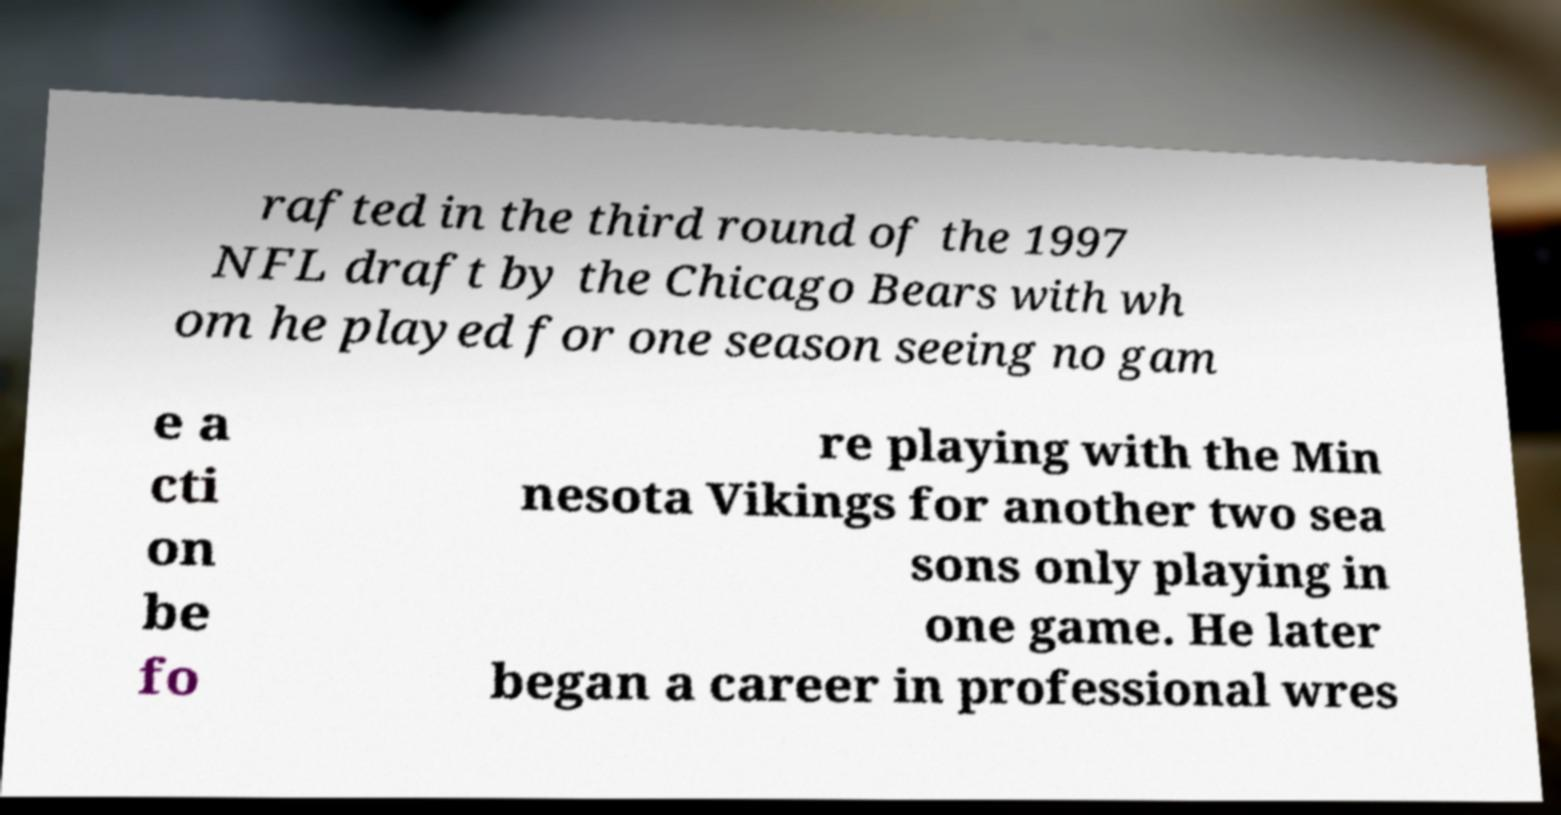Please read and relay the text visible in this image. What does it say? rafted in the third round of the 1997 NFL draft by the Chicago Bears with wh om he played for one season seeing no gam e a cti on be fo re playing with the Min nesota Vikings for another two sea sons only playing in one game. He later began a career in professional wres 